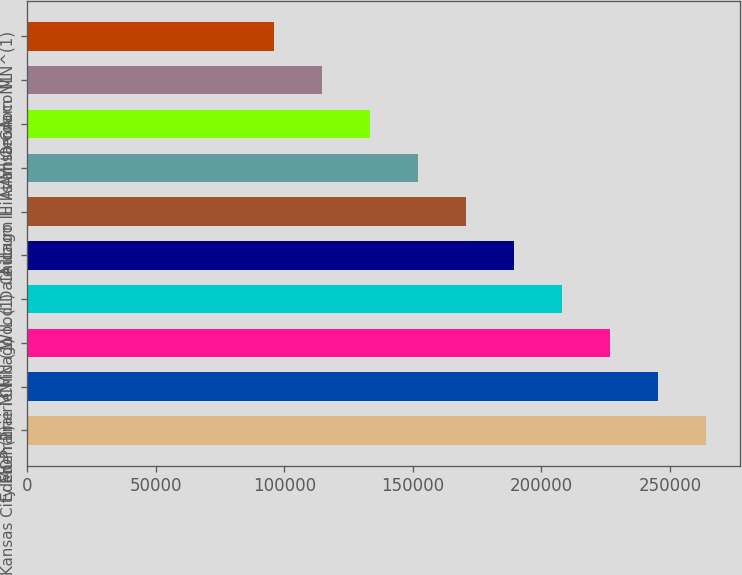Convert chart. <chart><loc_0><loc_0><loc_500><loc_500><bar_chart><fcel>Kansas City MO^(1)<fcel>Eden Prairie MN<fcel>Eden Prairie MN (1)<fcel>Chicago IL (1)<fcel>Wood Dale IL<fcel>Chicago IL<fcel>Auburn Hills MI<fcel>Atlanta GA<fcel>Amsterdam NL<fcel>Oronoco MN^(1)<nl><fcel>264100<fcel>245400<fcel>226700<fcel>208000<fcel>189300<fcel>170600<fcel>151900<fcel>133200<fcel>114500<fcel>95800<nl></chart> 